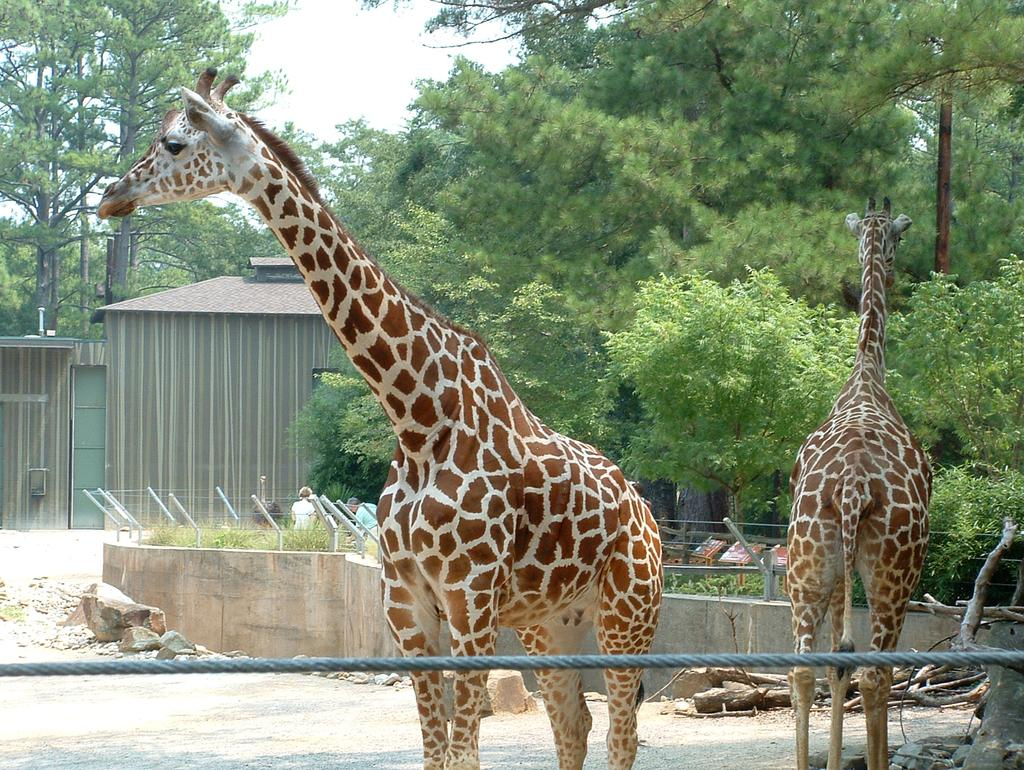What object can be seen in the image? There is a rope in the image. What is located behind the rope? There are giraffes behind the rope. What can be seen in the background of the image? There are trees, people, and the sky visible in the background of the image. What type of pen is being used by the giraffes in the image? There are no pens present in the image, as it features a rope and giraffes. 